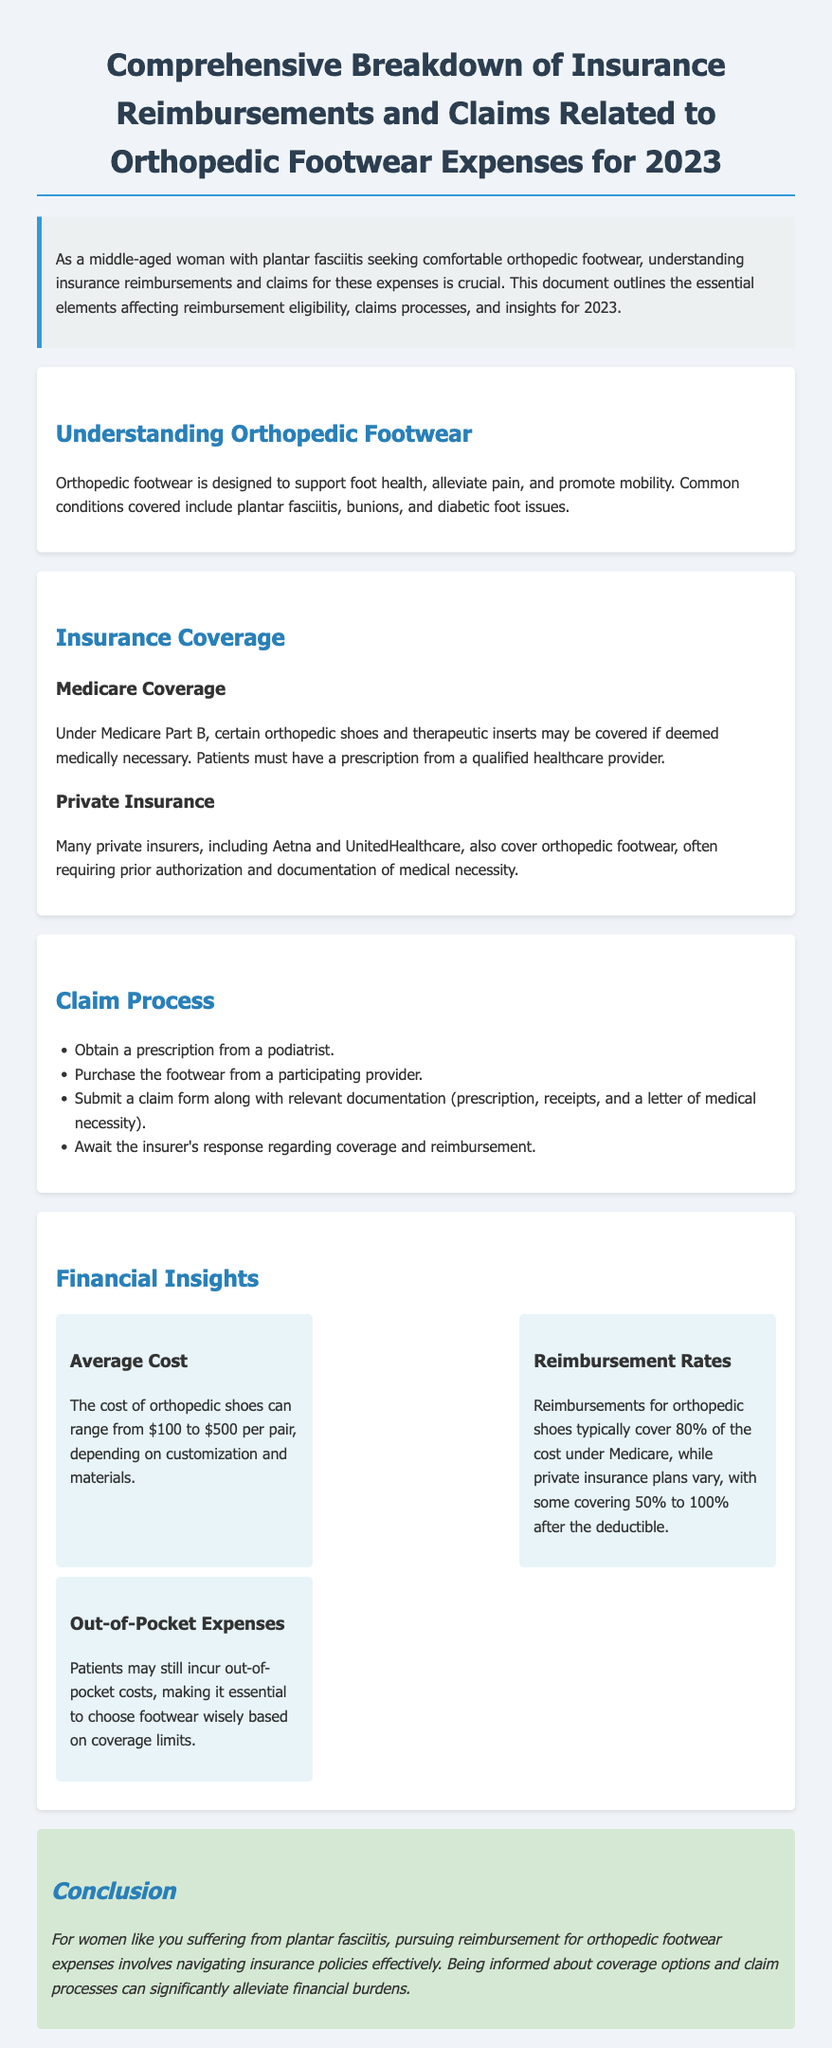What is the average cost of orthopedic shoes? The average cost of orthopedic shoes can range significantly, which is mentioned as between $100 to $500 per pair.
Answer: $100 to $500 What percentage does Medicare cover for orthopedic shoes? The document states that Medicare typically covers 80% of the cost of orthopedic shoes.
Answer: 80% What kind of documentation is necessary for submitting a claim? The document lists multiple items needed for a claim submission, including prescription, receipts, and a letter of medical necessity.
Answer: Prescription, receipts, and letter of medical necessity Which private insurers are mentioned that cover orthopedic footwear? The document explicitly mentions Aetna and UnitedHealthcare as private insurers that cover orthopedic footwear.
Answer: Aetna and UnitedHealthcare What must patients have to qualify for Medicare coverage for orthopedic footwear? The document notes that a prescription from a qualified healthcare provider is necessary to qualify for Medicare coverage.
Answer: Prescription What can contribute to out-of-pocket expenses for patients? The necessity to choose footwear wisely based on coverage limits is noted to contribute to out-of-pocket expenses.
Answer: Coverage limits What is the first step in the claim process mentioned in the document? The document outlines that obtaining a prescription from a podiatrist is the first step in the claim process.
Answer: Obtain a prescription What condition is specifically mentioned as covered by orthopedic footwear? The document highlights plantar fasciitis as one of the common conditions for which orthopedic footwear is designed.
Answer: Plantar fasciitis 